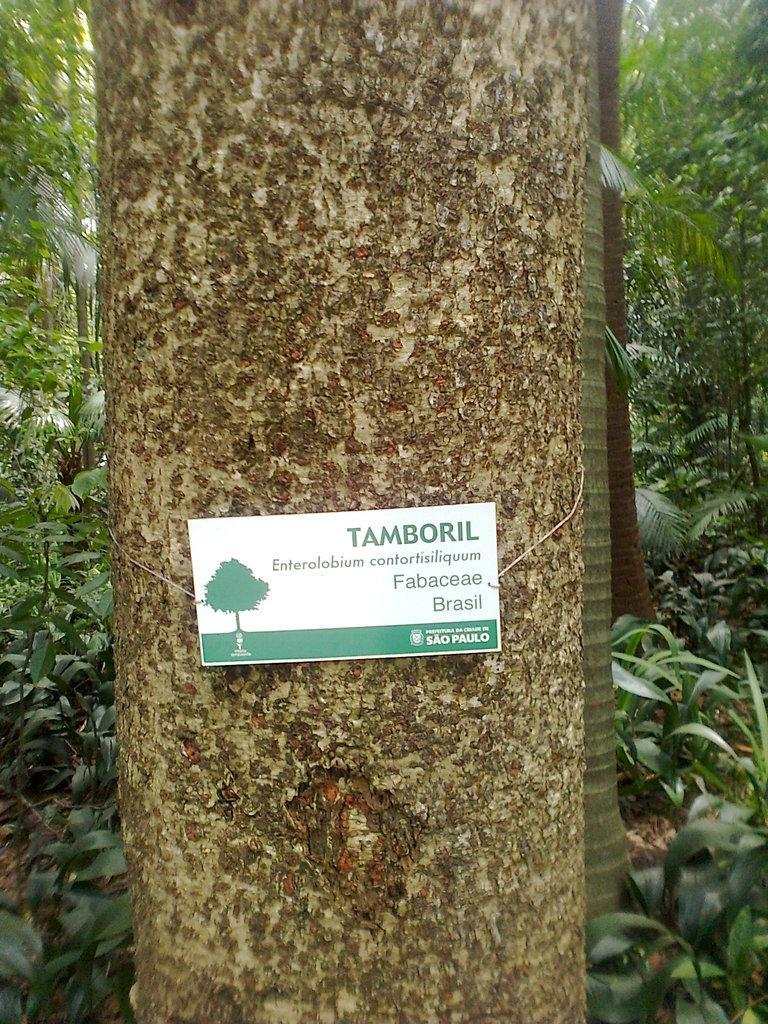Please provide a concise description of this image. In this image there is a card with some text attached to the trunk of the tree, there are few trees and plants. 